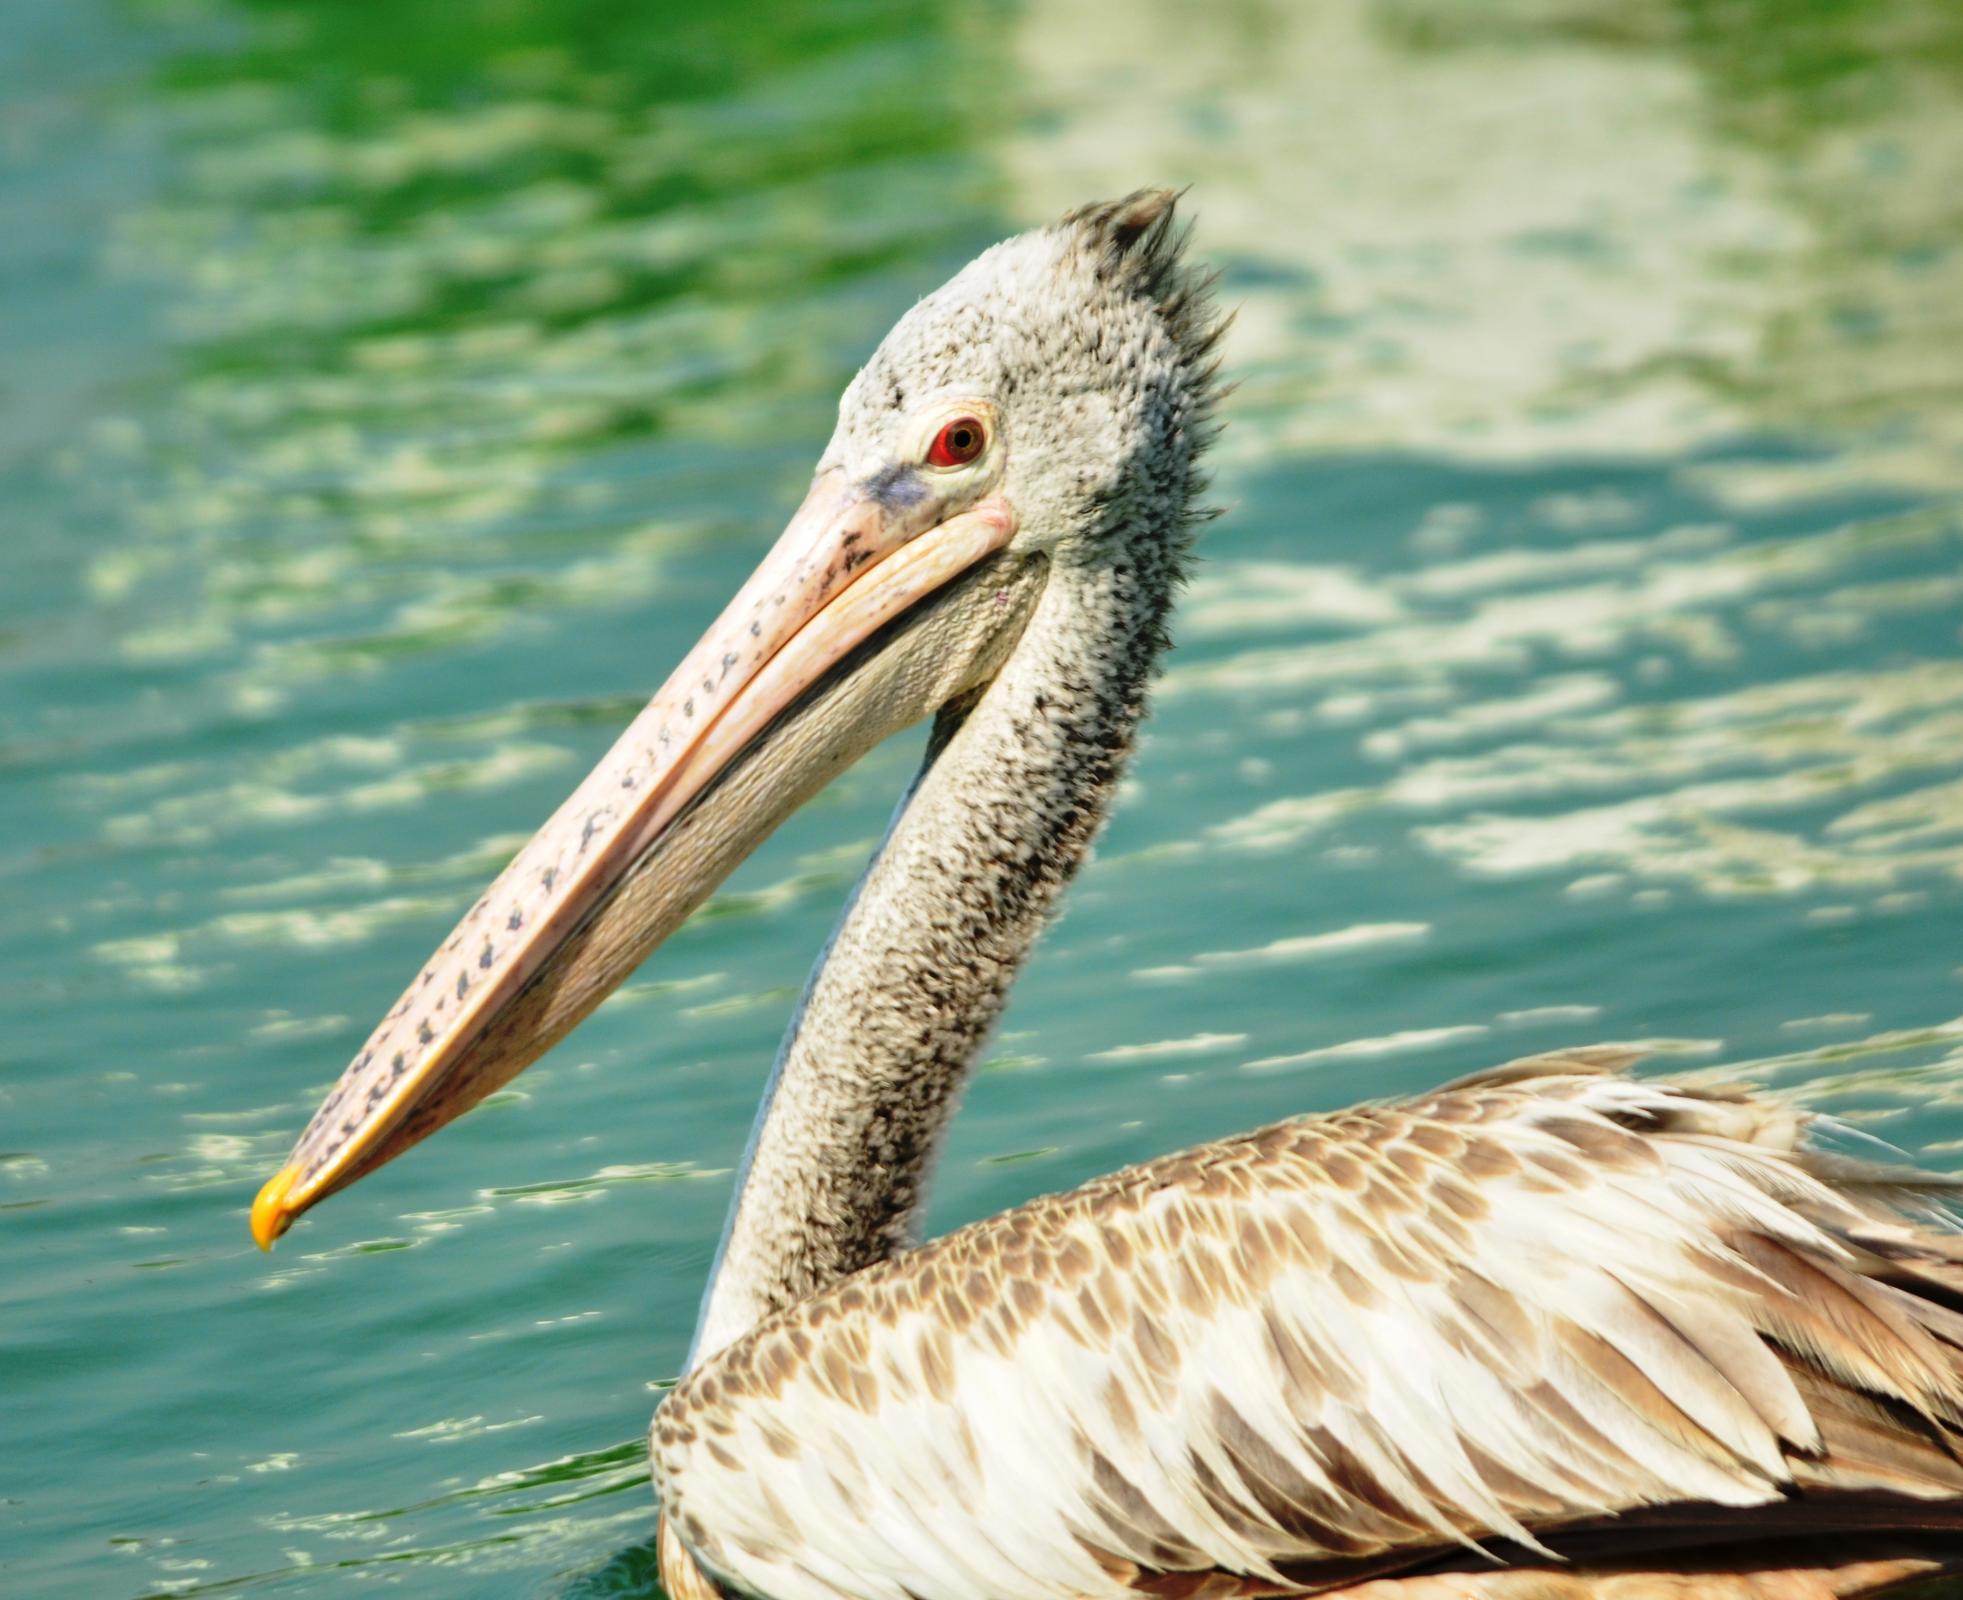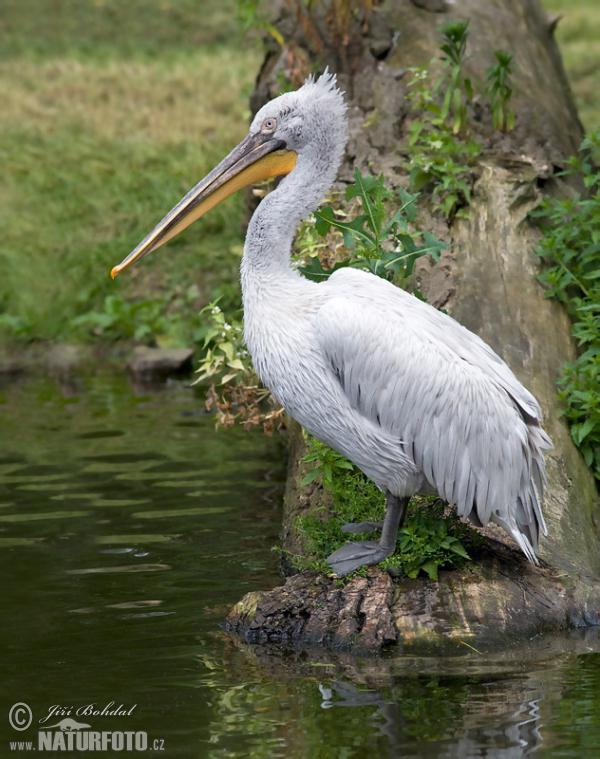The first image is the image on the left, the second image is the image on the right. Examine the images to the left and right. Is the description "One of the birds is sitting on water." accurate? Answer yes or no. Yes. 